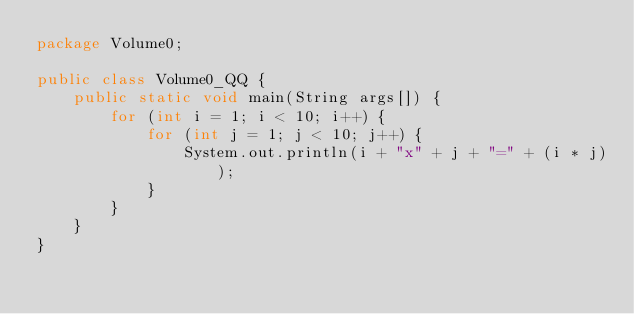Convert code to text. <code><loc_0><loc_0><loc_500><loc_500><_Java_>package Volume0;

public class Volume0_QQ {
	public static void main(String args[]) {
		for (int i = 1; i < 10; i++) {
			for (int j = 1; j < 10; j++) {
				System.out.println(i + "x" + j + "=" + (i * j));
			}
		}
	}
}</code> 